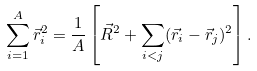Convert formula to latex. <formula><loc_0><loc_0><loc_500><loc_500>\sum _ { i = 1 } ^ { A } \vec { r } _ { i } ^ { 2 } = \frac { 1 } { A } \left [ \vec { R } ^ { 2 } + \sum _ { i < j } ( \vec { r } _ { i } - \vec { r } _ { j } ) ^ { 2 } \right ] .</formula> 